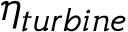Convert formula to latex. <formula><loc_0><loc_0><loc_500><loc_500>\eta _ { t u r b i n e }</formula> 